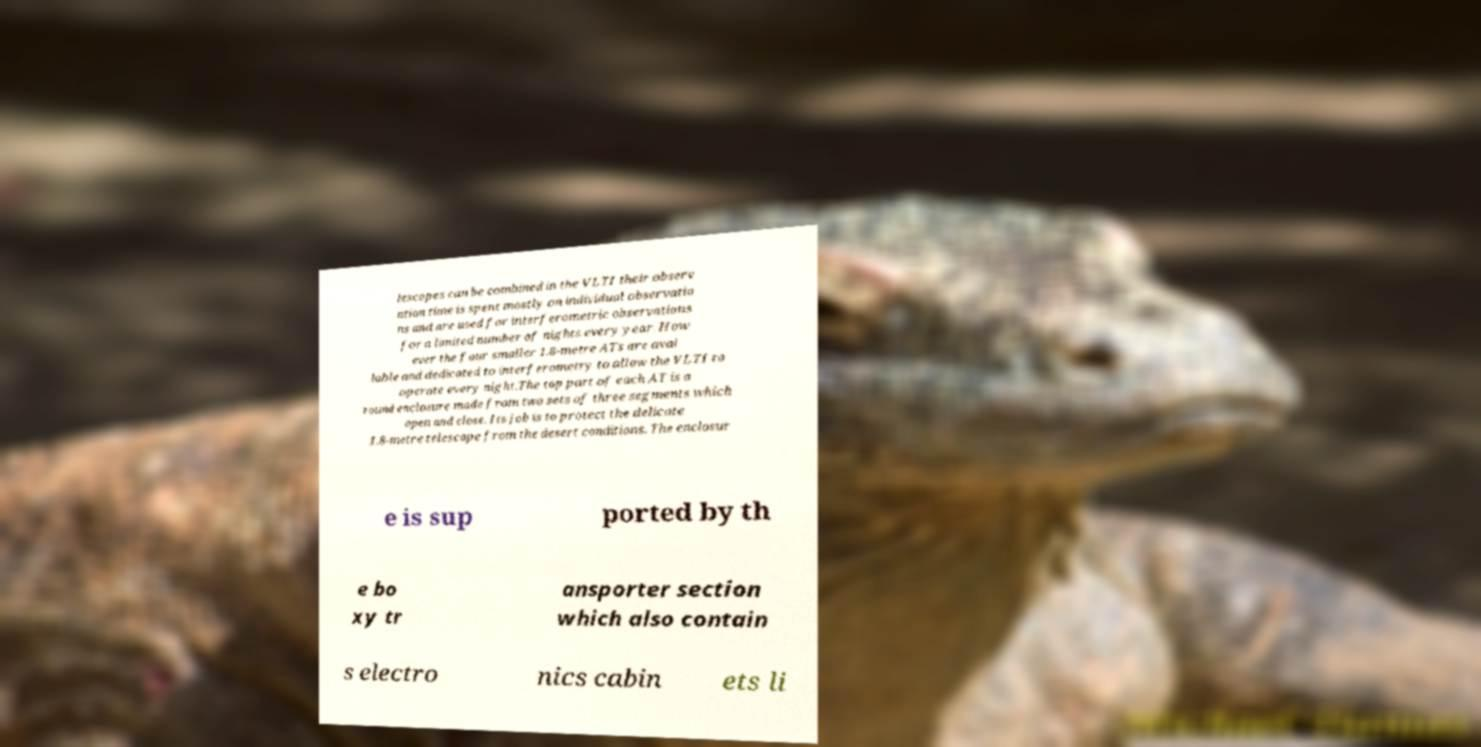Please read and relay the text visible in this image. What does it say? lescopes can be combined in the VLTI their observ ation time is spent mostly on individual observatio ns and are used for interferometric observations for a limited number of nights every year. How ever the four smaller 1.8-metre ATs are avai lable and dedicated to interferometry to allow the VLTI to operate every night.The top part of each AT is a round enclosure made from two sets of three segments which open and close. Its job is to protect the delicate 1.8-metre telescope from the desert conditions. The enclosur e is sup ported by th e bo xy tr ansporter section which also contain s electro nics cabin ets li 